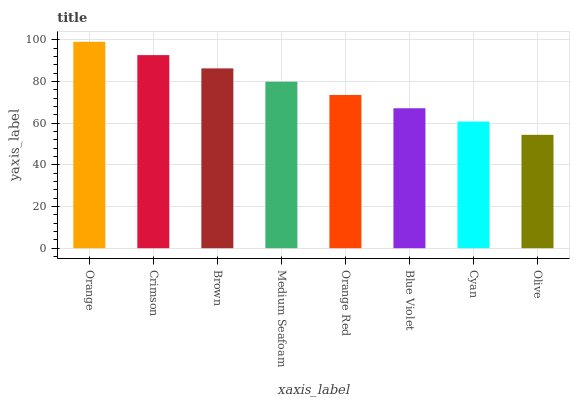Is Crimson the minimum?
Answer yes or no. No. Is Crimson the maximum?
Answer yes or no. No. Is Orange greater than Crimson?
Answer yes or no. Yes. Is Crimson less than Orange?
Answer yes or no. Yes. Is Crimson greater than Orange?
Answer yes or no. No. Is Orange less than Crimson?
Answer yes or no. No. Is Medium Seafoam the high median?
Answer yes or no. Yes. Is Orange Red the low median?
Answer yes or no. Yes. Is Orange Red the high median?
Answer yes or no. No. Is Brown the low median?
Answer yes or no. No. 